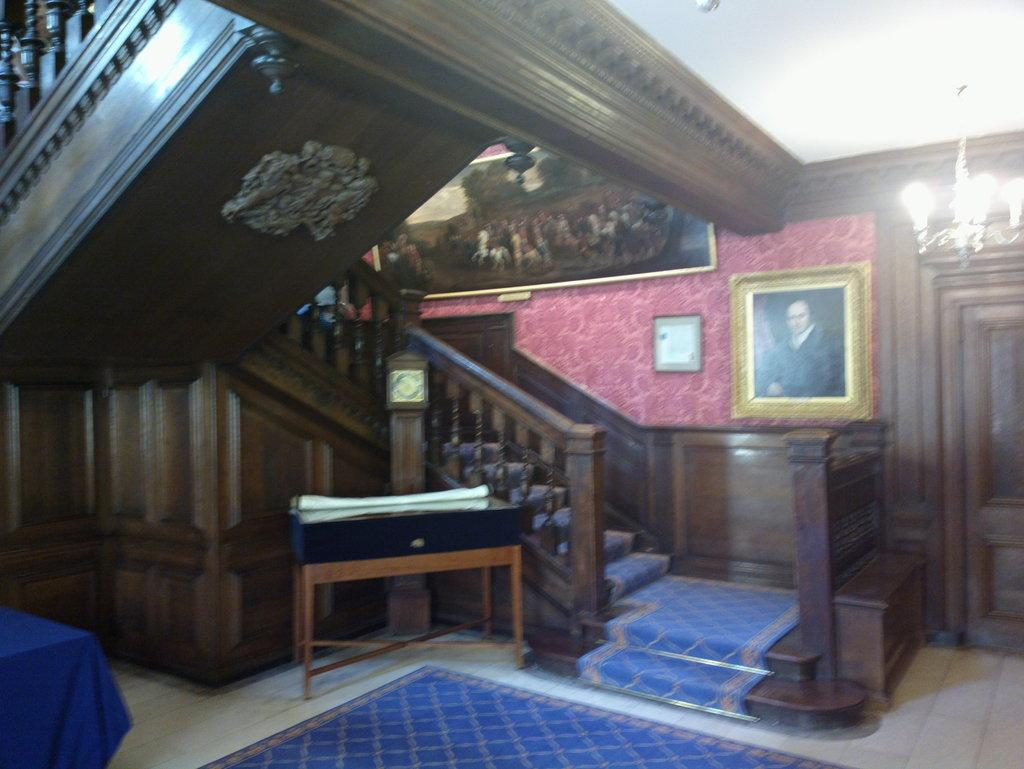What is located on the floor in the image? There is a floor mat in the image. What architectural feature is present in the image? There are stairs in the image. What part of the room can be seen in the image? The wall is visible in the image. What decorative items are attached to the wall in the image? There are photo frames attached to the wall in the image. What part of the room is above the image? The ceiling is visible in the image. What type of lighting fixture is present in the image? There is a chandelier in the image. What feature allows access to other parts of the building in the image? There is a door in the image. Can you tell me how many cats are taking a bath in the tub in the image? There is no cat or tub present in the image. What type of list is hanging on the wall in the image? There is no list present in the image; only photo frames are attached to the wall. 